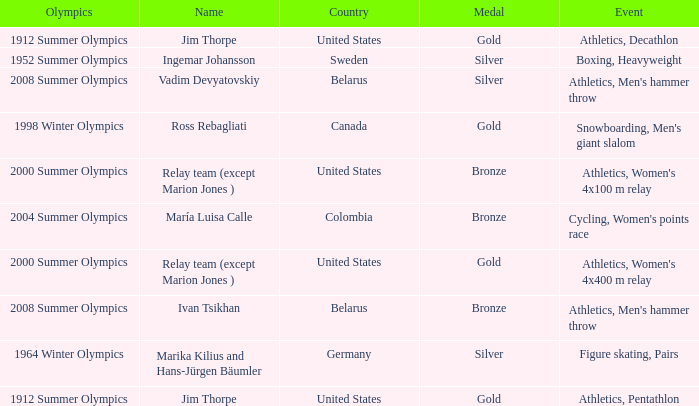Which event is in the 1952 summer olympics? Boxing, Heavyweight. 